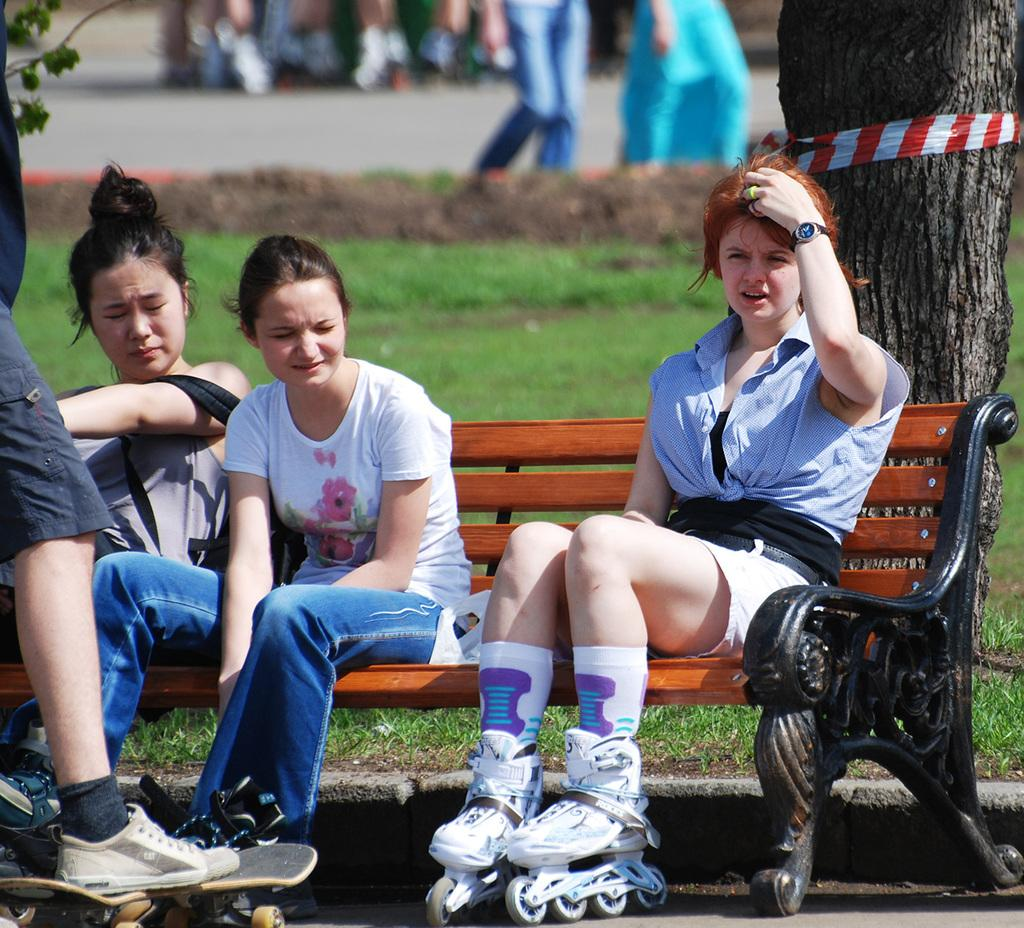How many women are sitting on the bench in the image? There are three women sitting on a bench in the image. What is the person in the image doing? The person is standing on a skateboard. What can be seen behind the people in the image? There is a tree trunk visible behind the people. Can you describe the background of the image? There are some blurred things in the background. What type of soap is being used by the person on the skateboard in the image? There is no soap present in the image; the person is standing on a skateboard. Can you tell me how many islands are visible in the image? There are no islands visible in the image. 